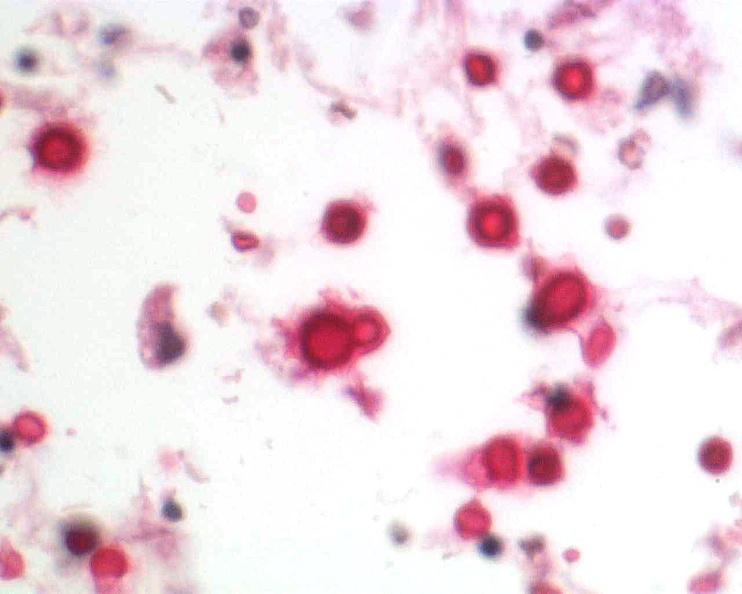do mucicarmine stain?
Answer the question using a single word or phrase. Yes 